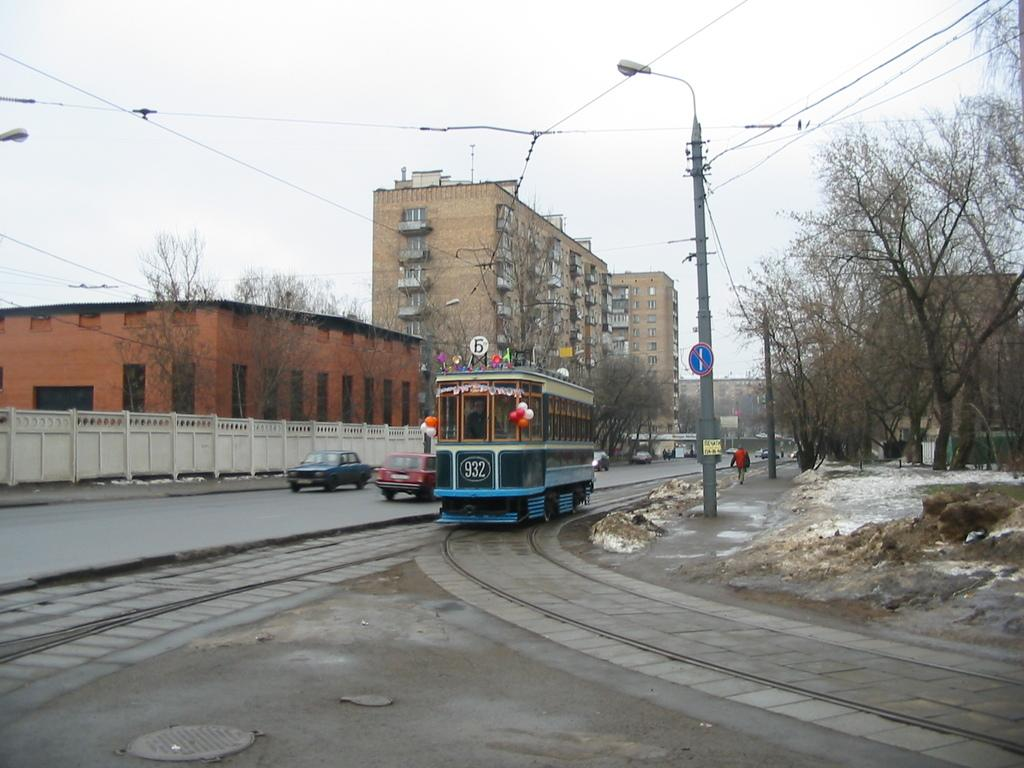<image>
Present a compact description of the photo's key features. Trolley number 932 is on the tracks in a snowy town. 